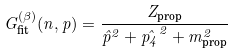<formula> <loc_0><loc_0><loc_500><loc_500>G ^ { ( \beta ) } _ { \text {fit} } ( n , { p } ) = { { \frac { Z _ { \text {prop} } } { \hat { p } ^ { 2 } + \hat { p _ { 4 } } ^ { 2 } + m ^ { 2 } _ { \text {prop} } } } }</formula> 